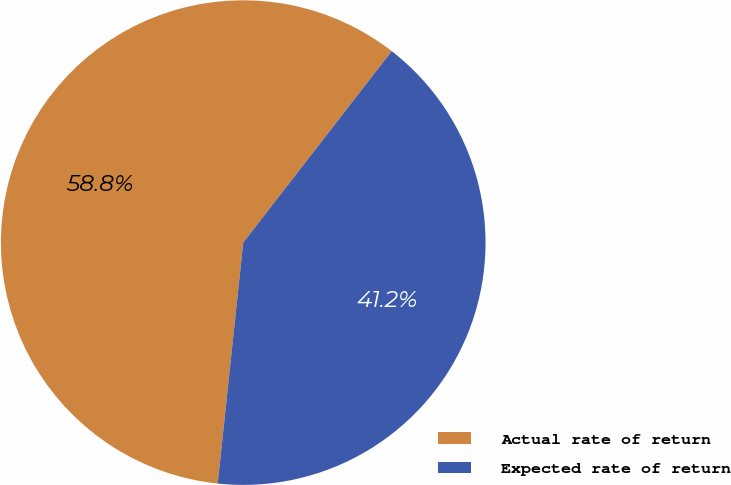<chart> <loc_0><loc_0><loc_500><loc_500><pie_chart><fcel>Actual rate of return<fcel>Expected rate of return<nl><fcel>58.82%<fcel>41.18%<nl></chart> 